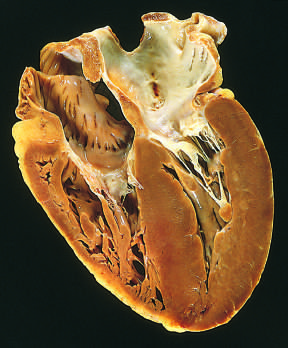where is the left ventricle in this apical four-chamber view of the heart?
Answer the question using a single word or phrase. On the lower right 